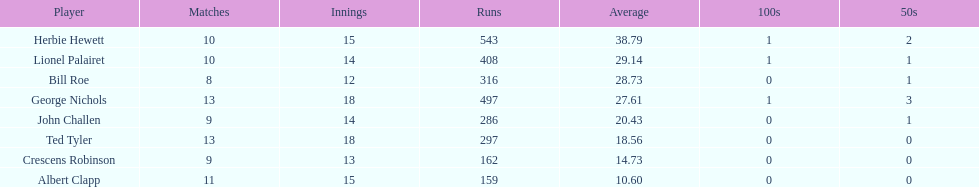What was the total number of runs ted tyler scored? 297. 